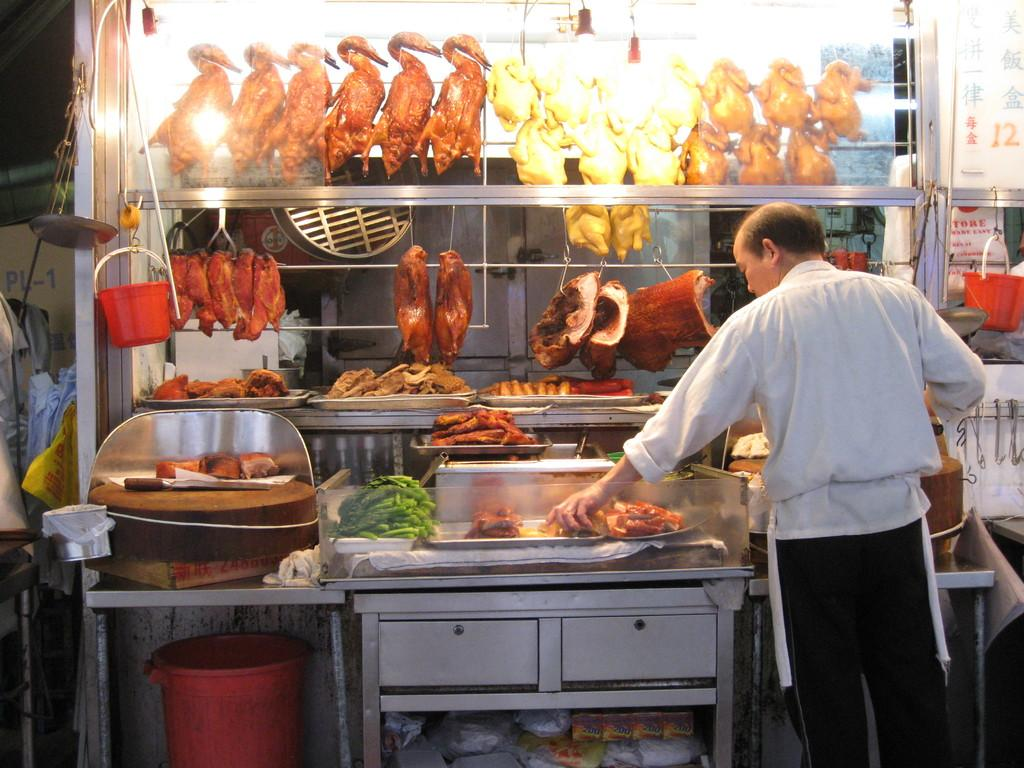What is the person in the image holding? The person is holding food in the image. What type of container is present in the image? There is a bin in the image. What kind of surface or path can be seen in the image? There is a track in the image. What event or gathering is depicted in the image? There is a meet in the image. What type of container is used for holding liquids or other materials in the image? There are buckets in the image. What utensil is visible in the image? There is a knife in the image. What type of pickle is being served in the jar at the meet? There is no jar or pickle present in the image. What type of apparel is the person wearing at the meet? The provided facts do not mention any apparel worn by the person in the image. 